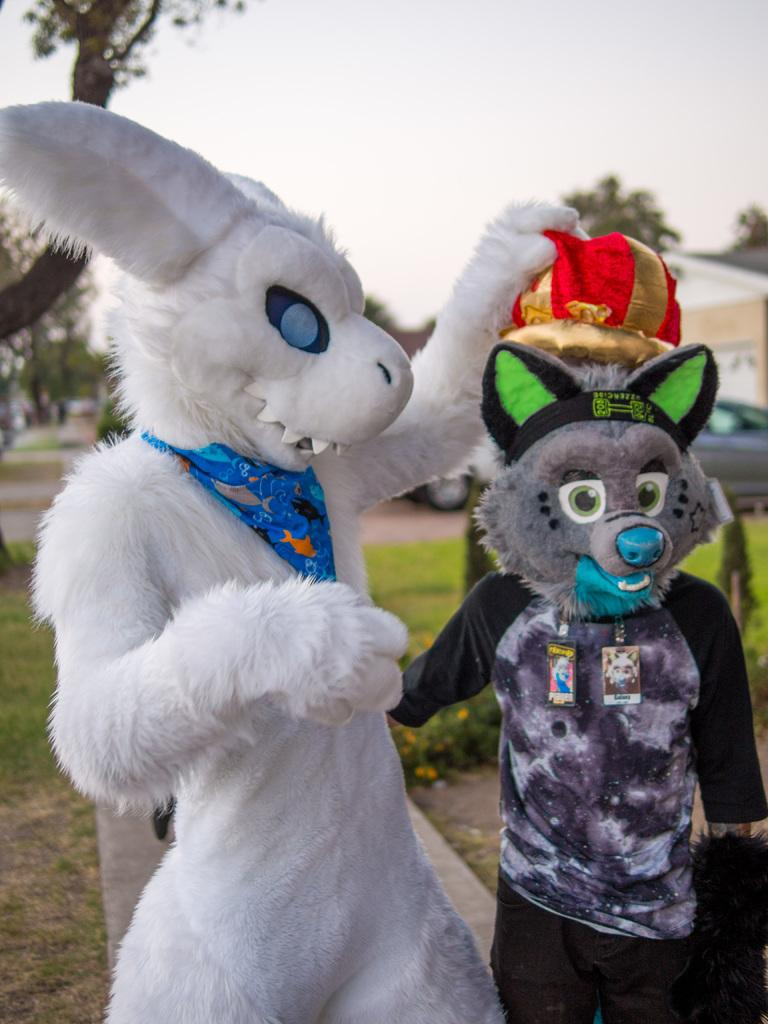Where was the image taken? The image was clicked outside. How many people are in the foreground of the image? There are two persons in the foreground of the image. What are the two persons dressed as? The two persons appear to be mascots. What can be seen in the background of the image? There is a sky, trees, vehicles, and other objects visible in the background of the image. What type of kite is being flown by one of the mascots in the image? There is no kite present in the image; the two persons are dressed as mascots. What type of door can be seen in the image? There is no door present in the image; it was taken outside. 